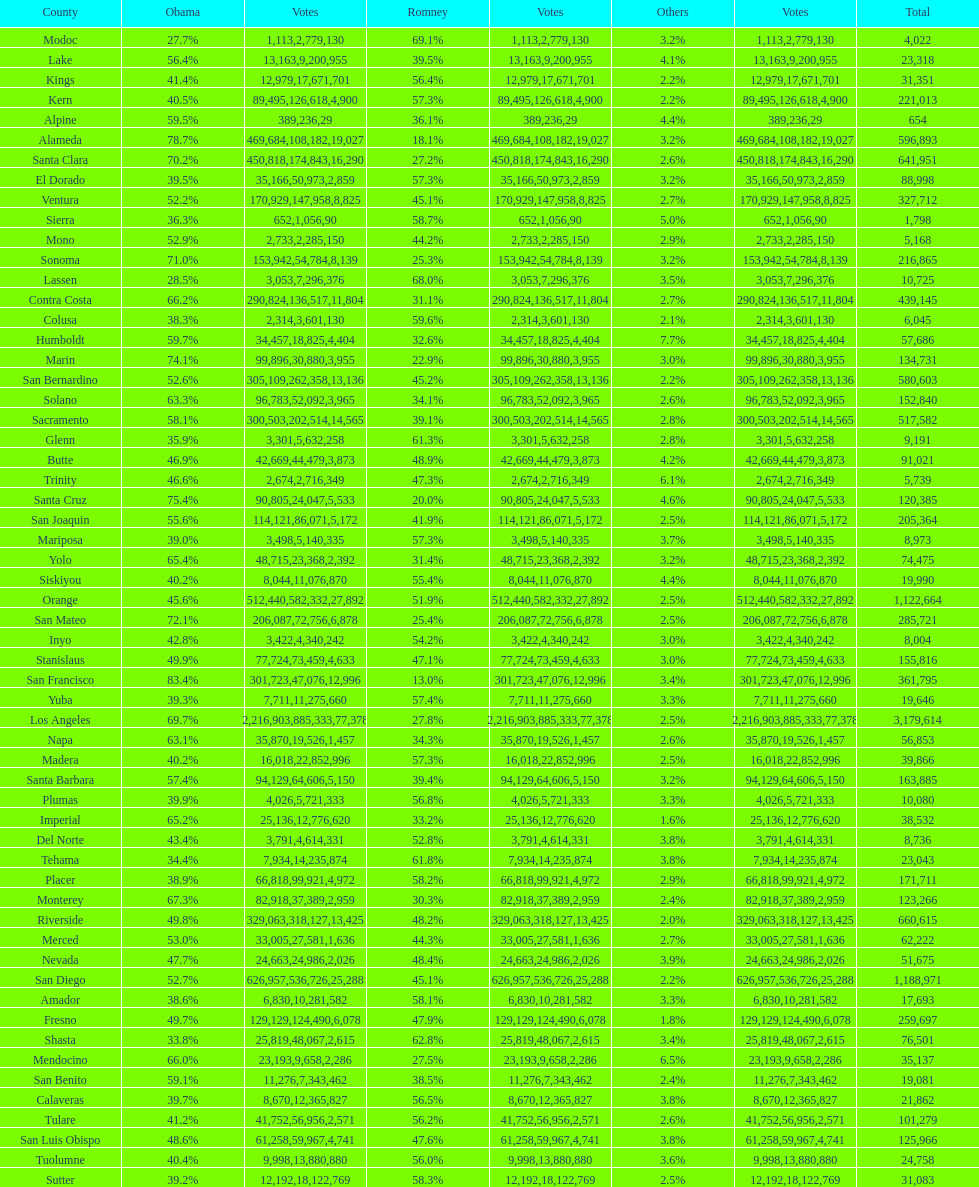Which county had the lower percentage votes for obama: amador, humboldt, or lake? Amador. 